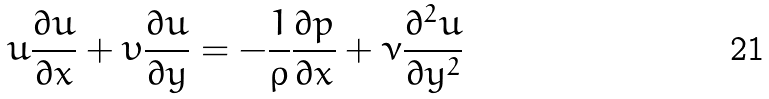<formula> <loc_0><loc_0><loc_500><loc_500>u { \frac { \partial u } { \partial x } } + \upsilon { \frac { \partial u } { \partial y } } = - { \frac { 1 } { \rho } } { \frac { \partial p } { \partial x } } + { \nu } { \frac { \partial ^ { 2 } u } { \partial y ^ { 2 } } }</formula> 